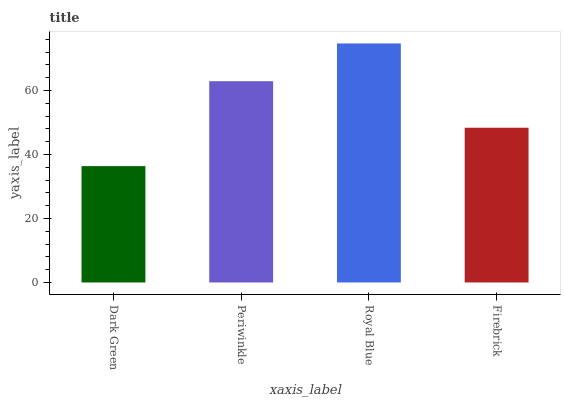Is Periwinkle the minimum?
Answer yes or no. No. Is Periwinkle the maximum?
Answer yes or no. No. Is Periwinkle greater than Dark Green?
Answer yes or no. Yes. Is Dark Green less than Periwinkle?
Answer yes or no. Yes. Is Dark Green greater than Periwinkle?
Answer yes or no. No. Is Periwinkle less than Dark Green?
Answer yes or no. No. Is Periwinkle the high median?
Answer yes or no. Yes. Is Firebrick the low median?
Answer yes or no. Yes. Is Royal Blue the high median?
Answer yes or no. No. Is Royal Blue the low median?
Answer yes or no. No. 